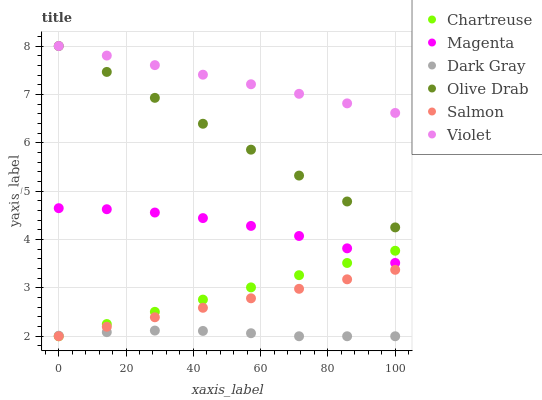Does Dark Gray have the minimum area under the curve?
Answer yes or no. Yes. Does Violet have the maximum area under the curve?
Answer yes or no. Yes. Does Chartreuse have the minimum area under the curve?
Answer yes or no. No. Does Chartreuse have the maximum area under the curve?
Answer yes or no. No. Is Chartreuse the smoothest?
Answer yes or no. Yes. Is Magenta the roughest?
Answer yes or no. Yes. Is Dark Gray the smoothest?
Answer yes or no. No. Is Dark Gray the roughest?
Answer yes or no. No. Does Salmon have the lowest value?
Answer yes or no. Yes. Does Violet have the lowest value?
Answer yes or no. No. Does Olive Drab have the highest value?
Answer yes or no. Yes. Does Chartreuse have the highest value?
Answer yes or no. No. Is Magenta less than Olive Drab?
Answer yes or no. Yes. Is Violet greater than Dark Gray?
Answer yes or no. Yes. Does Dark Gray intersect Chartreuse?
Answer yes or no. Yes. Is Dark Gray less than Chartreuse?
Answer yes or no. No. Is Dark Gray greater than Chartreuse?
Answer yes or no. No. Does Magenta intersect Olive Drab?
Answer yes or no. No. 